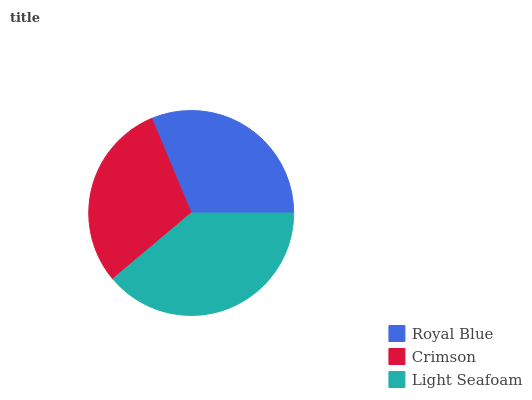Is Crimson the minimum?
Answer yes or no. Yes. Is Light Seafoam the maximum?
Answer yes or no. Yes. Is Light Seafoam the minimum?
Answer yes or no. No. Is Crimson the maximum?
Answer yes or no. No. Is Light Seafoam greater than Crimson?
Answer yes or no. Yes. Is Crimson less than Light Seafoam?
Answer yes or no. Yes. Is Crimson greater than Light Seafoam?
Answer yes or no. No. Is Light Seafoam less than Crimson?
Answer yes or no. No. Is Royal Blue the high median?
Answer yes or no. Yes. Is Royal Blue the low median?
Answer yes or no. Yes. Is Light Seafoam the high median?
Answer yes or no. No. Is Light Seafoam the low median?
Answer yes or no. No. 